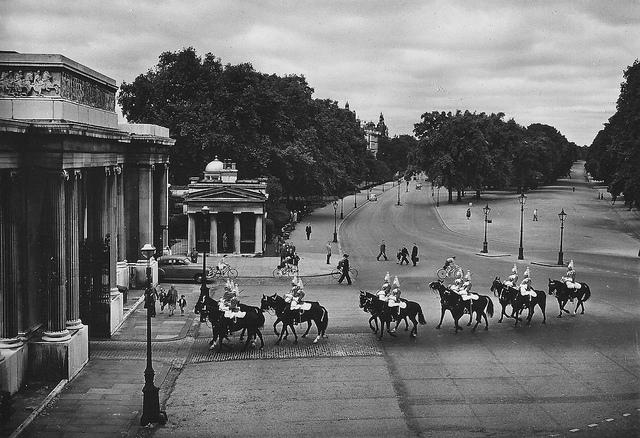What kind of building is it on the left?

Choices:
A) hotel
B) government building
C) residential building
D) shopping mall government building 